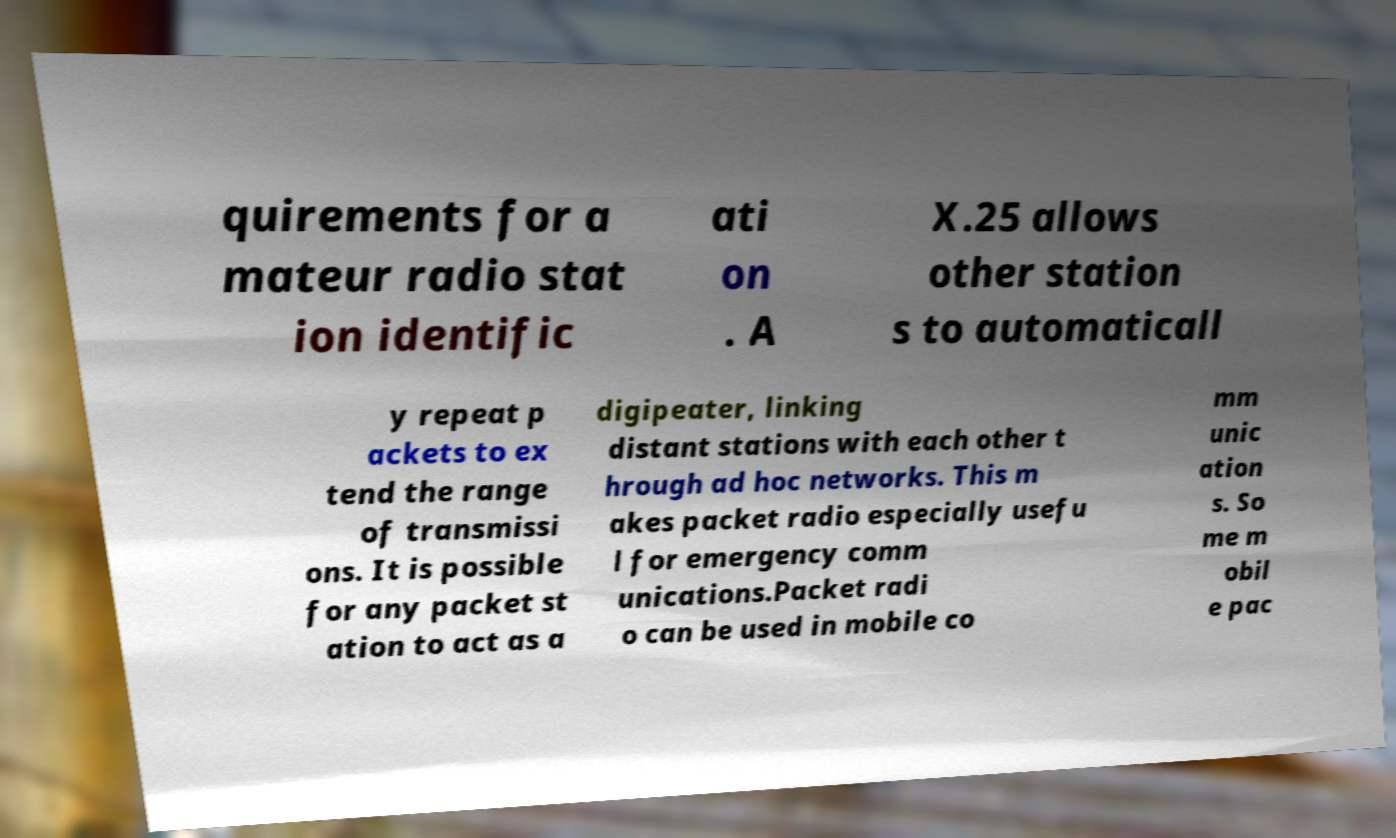What messages or text are displayed in this image? I need them in a readable, typed format. quirements for a mateur radio stat ion identific ati on . A X.25 allows other station s to automaticall y repeat p ackets to ex tend the range of transmissi ons. It is possible for any packet st ation to act as a digipeater, linking distant stations with each other t hrough ad hoc networks. This m akes packet radio especially usefu l for emergency comm unications.Packet radi o can be used in mobile co mm unic ation s. So me m obil e pac 